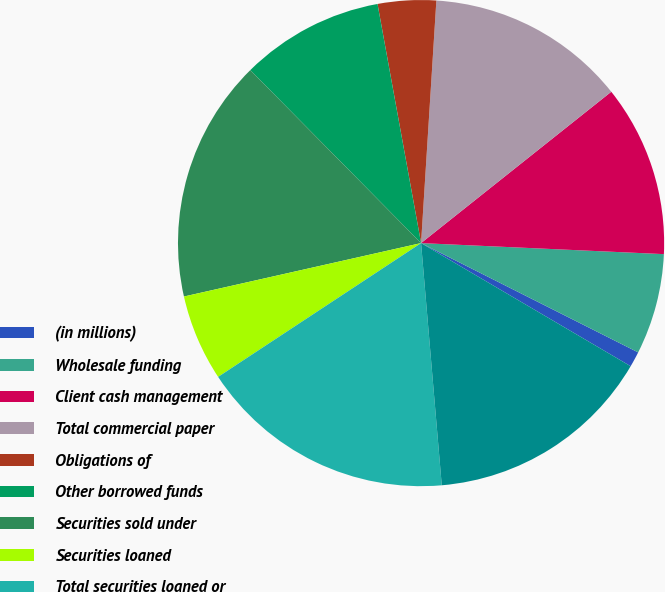Convert chart. <chart><loc_0><loc_0><loc_500><loc_500><pie_chart><fcel>(in millions)<fcel>Wholesale funding<fcel>Client cash management<fcel>Total commercial paper<fcel>Obligations of<fcel>Other borrowed funds<fcel>Securities sold under<fcel>Securities loaned<fcel>Total securities loaned or<fcel>Total senior notes<nl><fcel>1.03%<fcel>6.7%<fcel>11.42%<fcel>13.3%<fcel>3.87%<fcel>9.53%<fcel>16.13%<fcel>5.75%<fcel>17.08%<fcel>15.19%<nl></chart> 